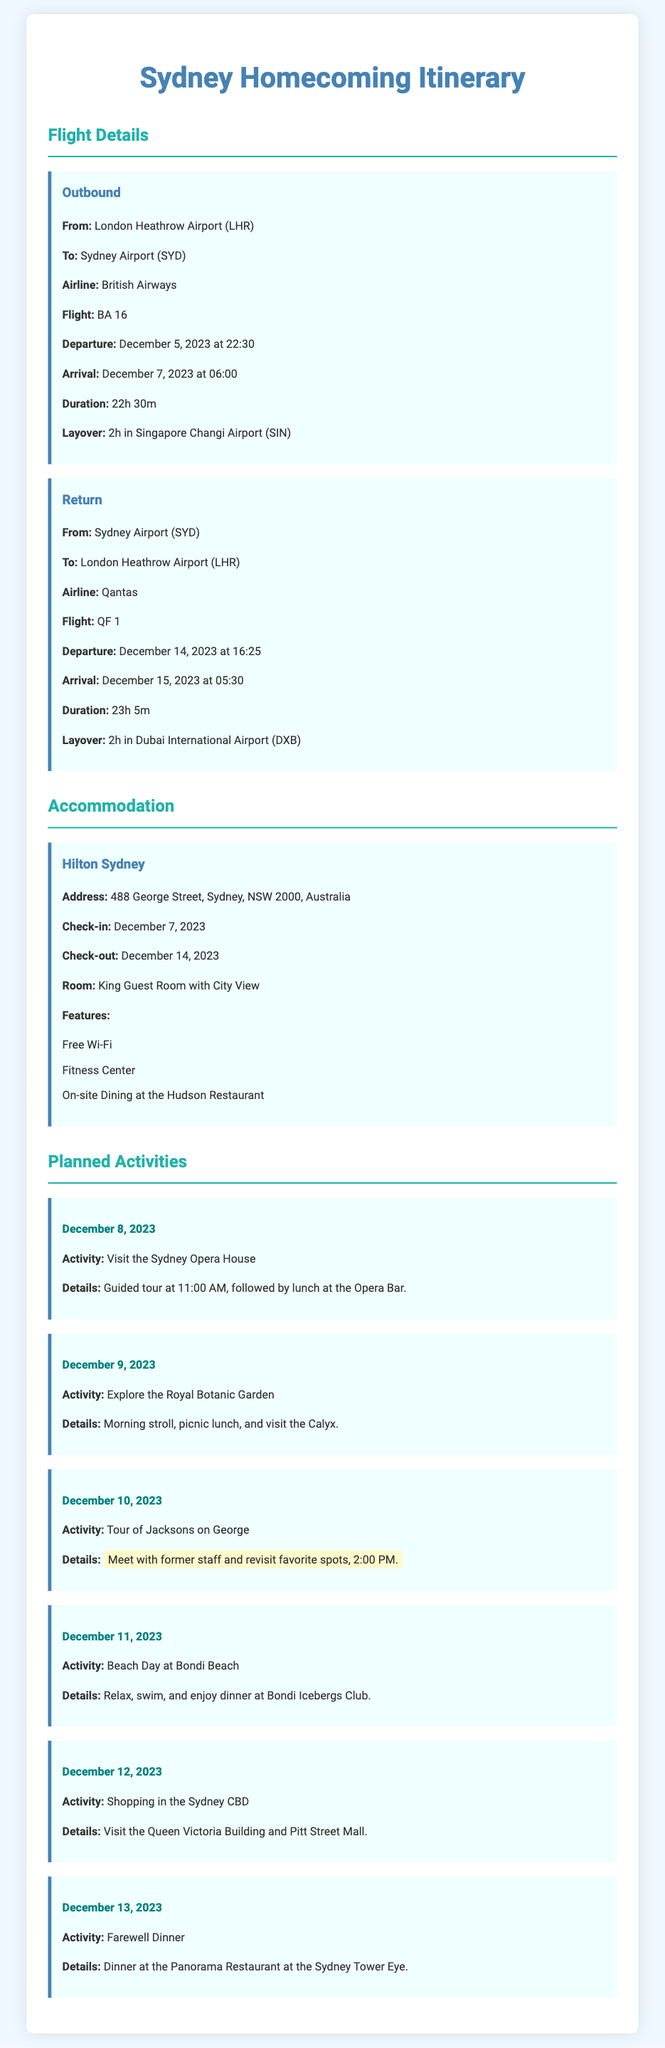What is the departure time for the outbound flight? The document states that the departure time for the outbound flight is December 5, 2023 at 22:30.
Answer: December 5, 2023 at 22:30 What hotel will you be staying in? The document lists Hilton Sydney as the accommodation for the trip.
Answer: Hilton Sydney What date is the tour of Jacksons on George scheduled for? The activity scheduled for the tour of Jacksons on George is on December 10, 2023.
Answer: December 10, 2023 How long is the layover on the outbound flight? The document shows that the layover on the outbound flight is 2 hours in Singapore Changi Airport.
Answer: 2 hours What is the check-out date for the hotel? The check-out date for the Hilton Sydney is mentioned as December 14, 2023.
Answer: December 14, 2023 What activity is planned for December 11, 2023? The planned activity for December 11, 2023, is a Beach Day at Bondi Beach.
Answer: Beach Day at Bondi Beach What is the flight number for the return trip? The document specifies that the flight number for the return trip is QF 1.
Answer: QF 1 What feature does the Hilton Sydney offer? The document lists free Wi-Fi as one of the features of Hilton Sydney.
Answer: Free Wi-Fi How long is the return flight duration? The document states that the duration of the return flight is 23 hours and 5 minutes.
Answer: 23h 5m 